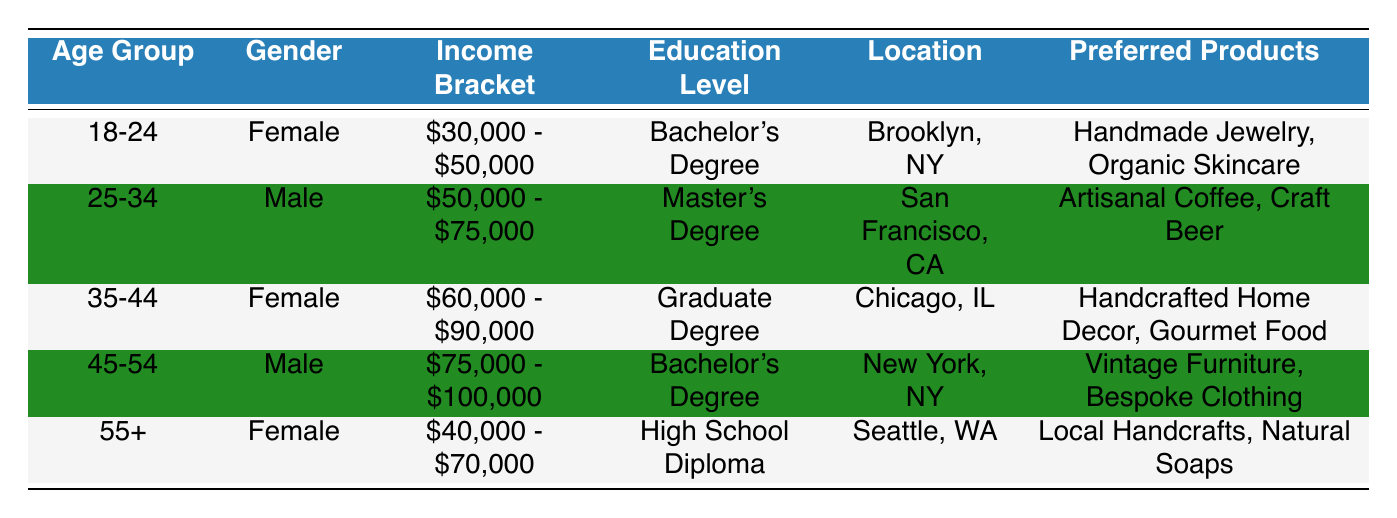What is the most preferred product among customers aged 35-44? In the row corresponding to the age group 35-44, the preferred products listed are handcrafted home decor and gourmet food. Since both are mentioned, there is no single "most preferred" product. However, they are the only preferred products for this age group.
Answer: Handcrafted home decor, gourmet food Which gender has a higher representation in the 45-54 age group? The table shows that the gender for the 45-54 age group is Male, and there are no additional males in this age group to compare to. Since only males are listed here, it follows that males are the only gender represented in this age group.
Answer: Male Is there any customer in the dataset whose income is below $30,000? Looking at the income brackets provided, the lowest range starts from $30,000 - $50,000. Since no customer demographic has an income bracket below $30,000, the answer is straightforward.
Answer: No What is the average age group for customers who prefer artisanal food products? The customers who prefer artisanal food products belong to the age groups 35-44 and 25-34 (gourmet food and artisanal coffee, respectively). To find the average, we can assign numerical values: 35-44 can be approximated to 39.5 years old average, and 25-34 can be approximated to 29.5 years old; thus, (39.5 + 29.5) / 2 = 34.
Answer: 34 Are there any customers from Seattle who prefer bespoke clothing? The table lists one customer from Seattle, aged 55+, who prefers local handcrafts and natural soaps. There is no customer from Seattle in the 45-54 age group who prefers bespoke clothing. Therefore, the answer is no.
Answer: No 